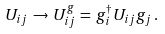<formula> <loc_0><loc_0><loc_500><loc_500>U _ { i j } \, \to \, U _ { i j } ^ { g } \, = \, g _ { i } ^ { \dagger } U _ { i j } g _ { j } \, .</formula> 